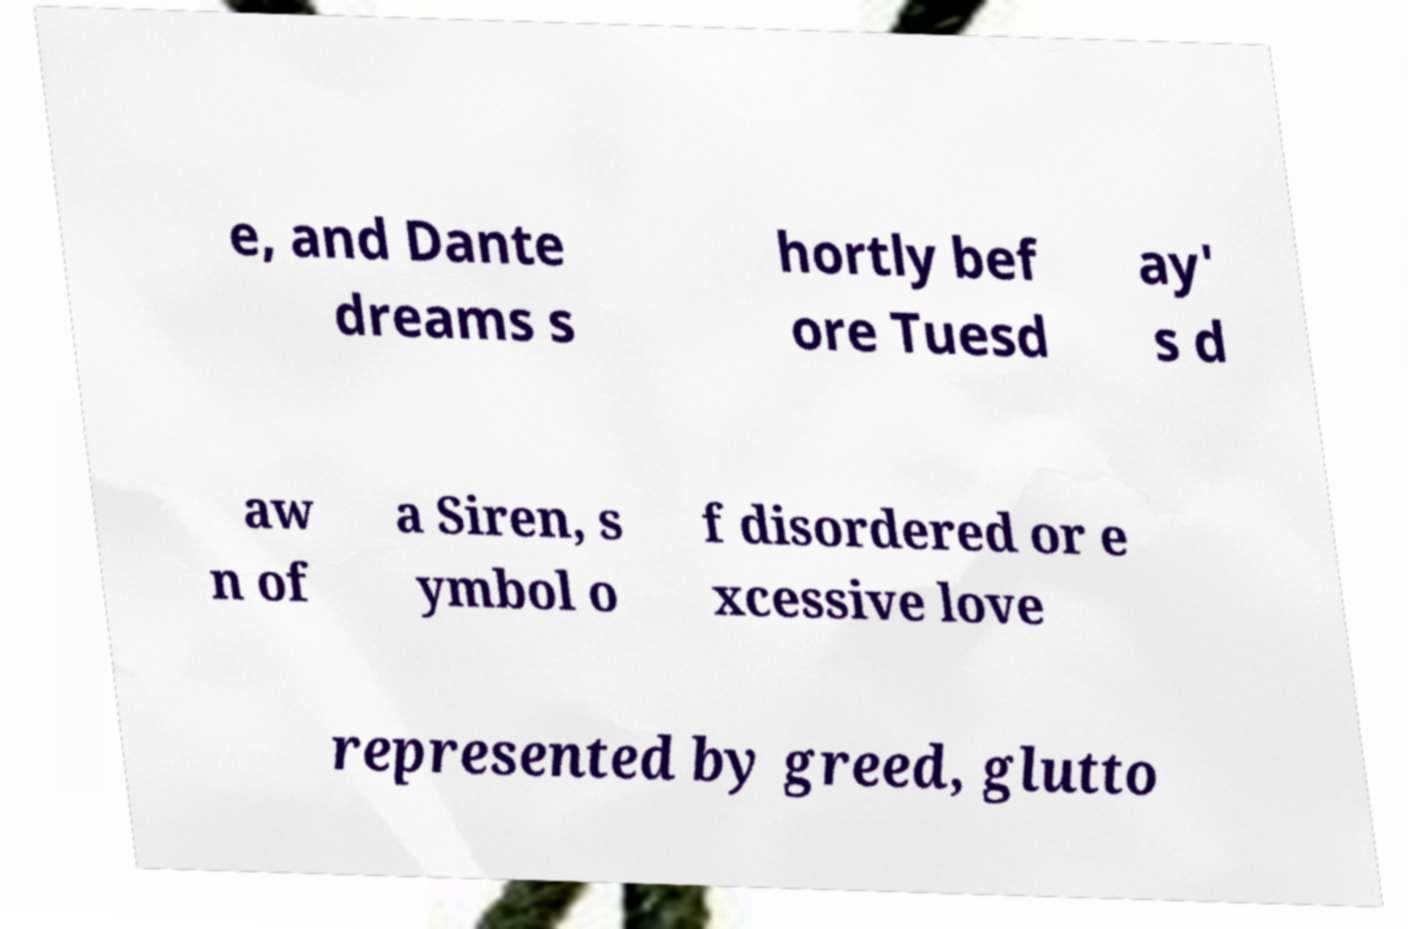Could you extract and type out the text from this image? e, and Dante dreams s hortly bef ore Tuesd ay' s d aw n of a Siren, s ymbol o f disordered or e xcessive love represented by greed, glutto 